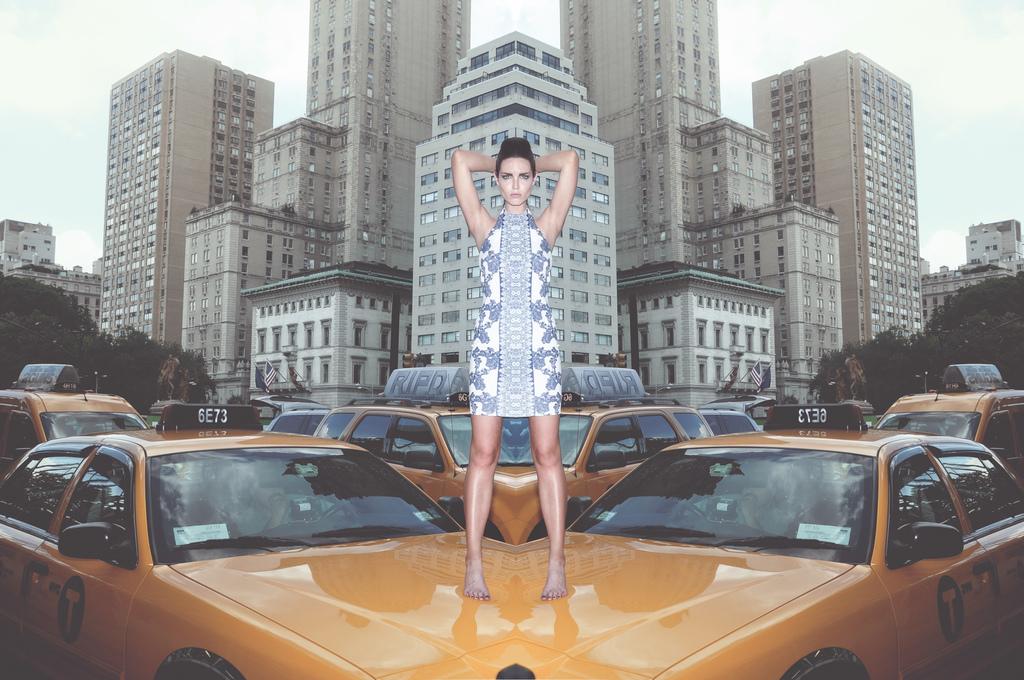What is the taxi number on the left?
Your answer should be very brief. 6e73. 